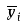Convert formula to latex. <formula><loc_0><loc_0><loc_500><loc_500>\overline { y } _ { i }</formula> 